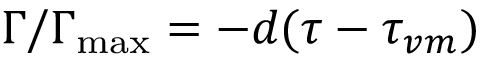<formula> <loc_0><loc_0><loc_500><loc_500>\Gamma / \Gamma _ { \max } = - d ( \tau - \tau _ { v m } )</formula> 